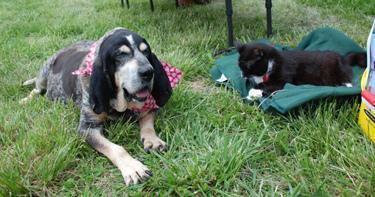How many dogs are pictured?
Give a very brief answer. 1. 